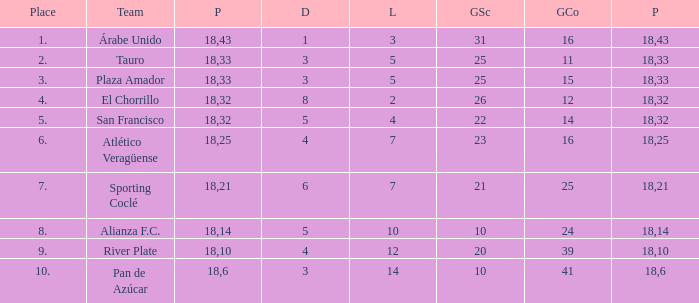How many goals were conceded by teams with 32 points, more than 2 losses and more than 22 goals scored? 0.0. 